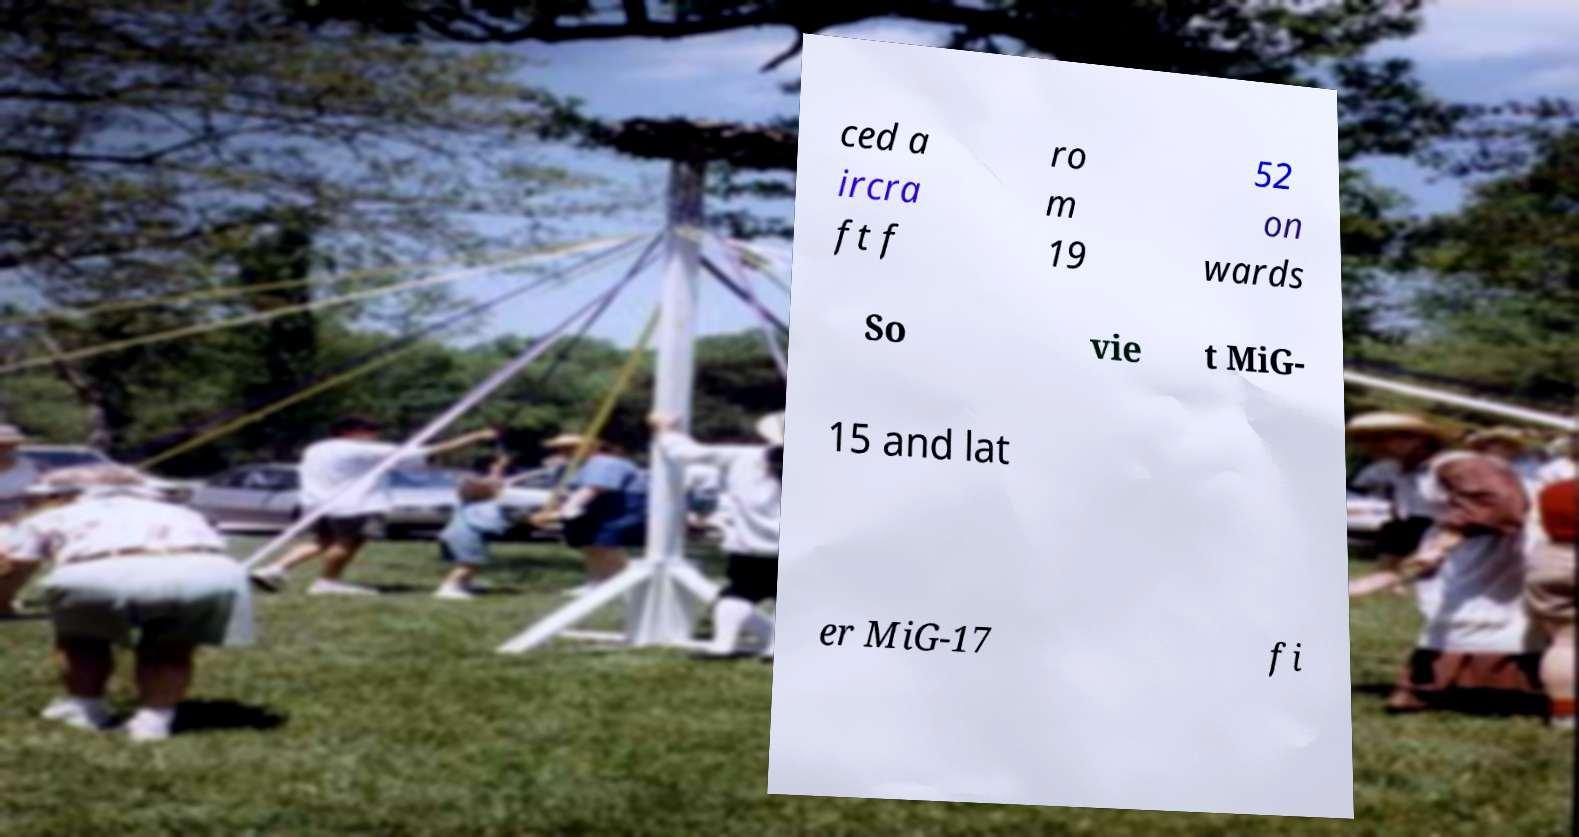There's text embedded in this image that I need extracted. Can you transcribe it verbatim? ced a ircra ft f ro m 19 52 on wards So vie t MiG- 15 and lat er MiG-17 fi 